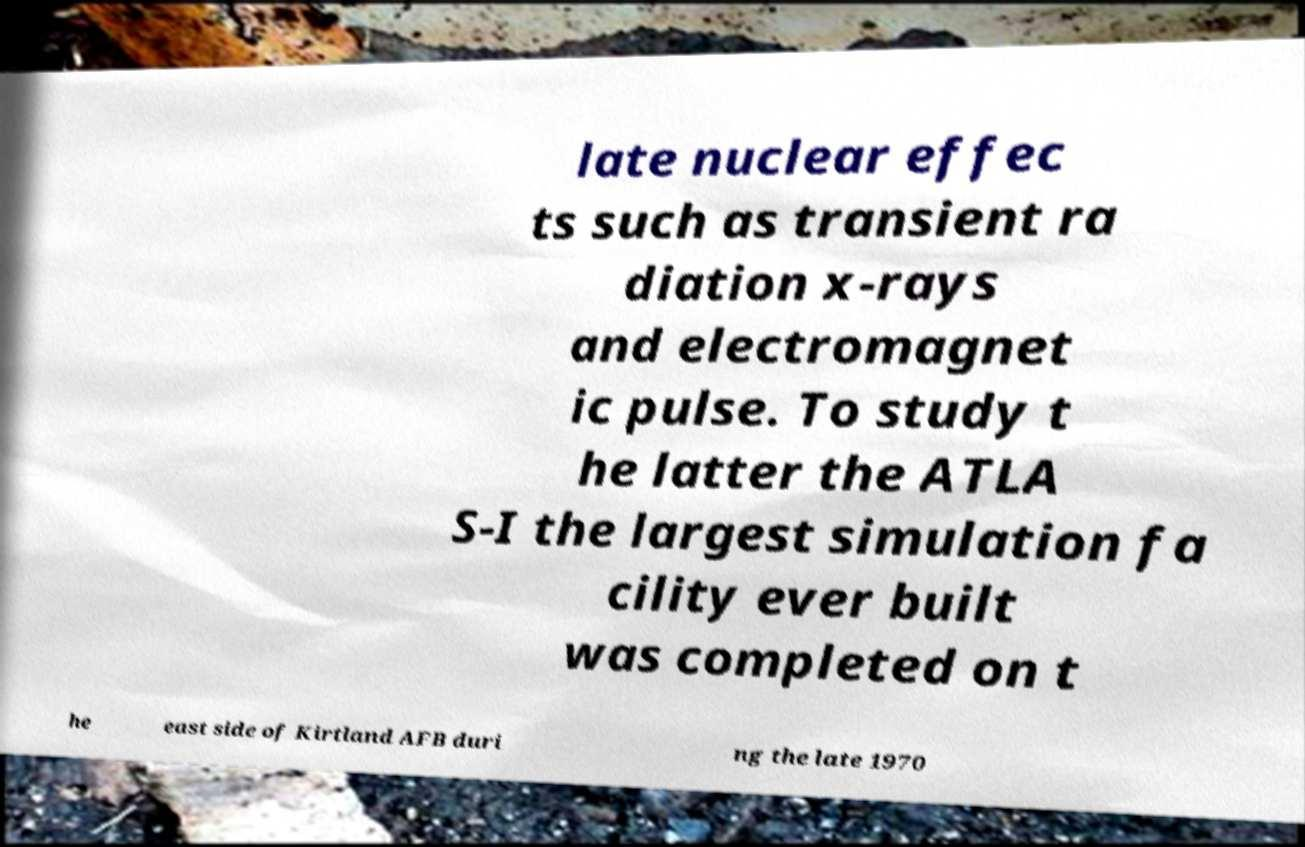Can you read and provide the text displayed in the image?This photo seems to have some interesting text. Can you extract and type it out for me? late nuclear effec ts such as transient ra diation x-rays and electromagnet ic pulse. To study t he latter the ATLA S-I the largest simulation fa cility ever built was completed on t he east side of Kirtland AFB duri ng the late 1970 